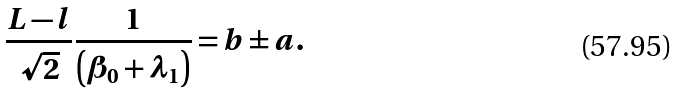<formula> <loc_0><loc_0><loc_500><loc_500>\frac { L - l } { \sqrt { 2 } } \frac { 1 } { \left ( \beta _ { 0 } + \lambda _ { 1 } \right ) } = b \pm a .</formula> 